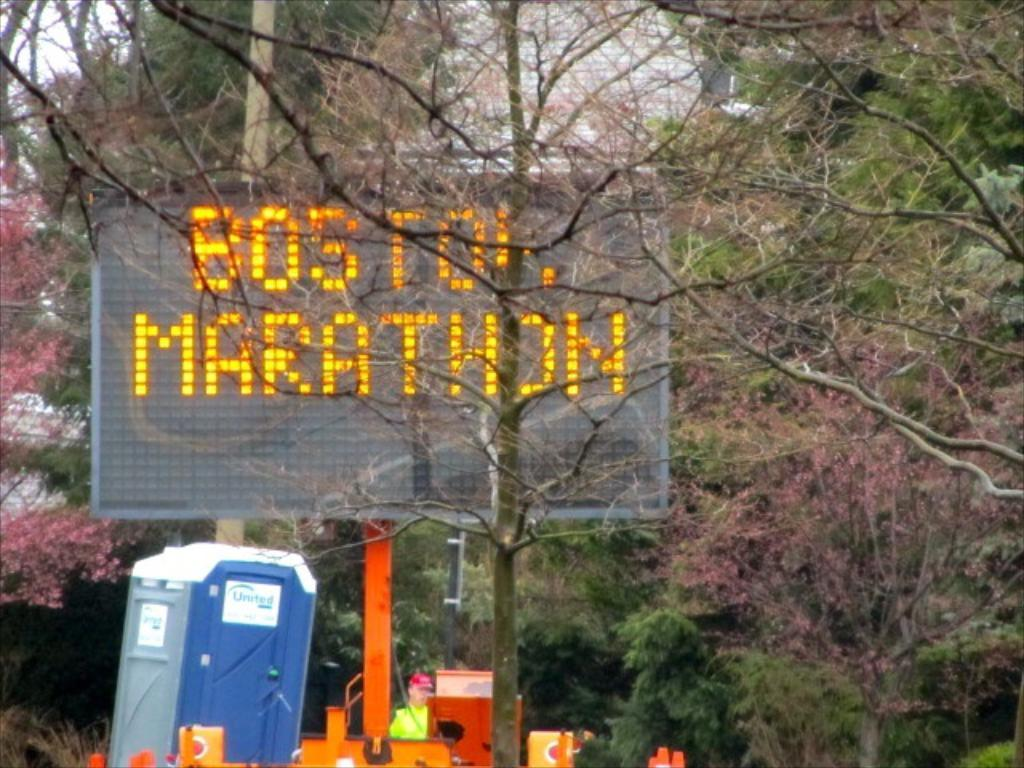<image>
Summarize the visual content of the image. a large sign for the Boston marathon in orange 